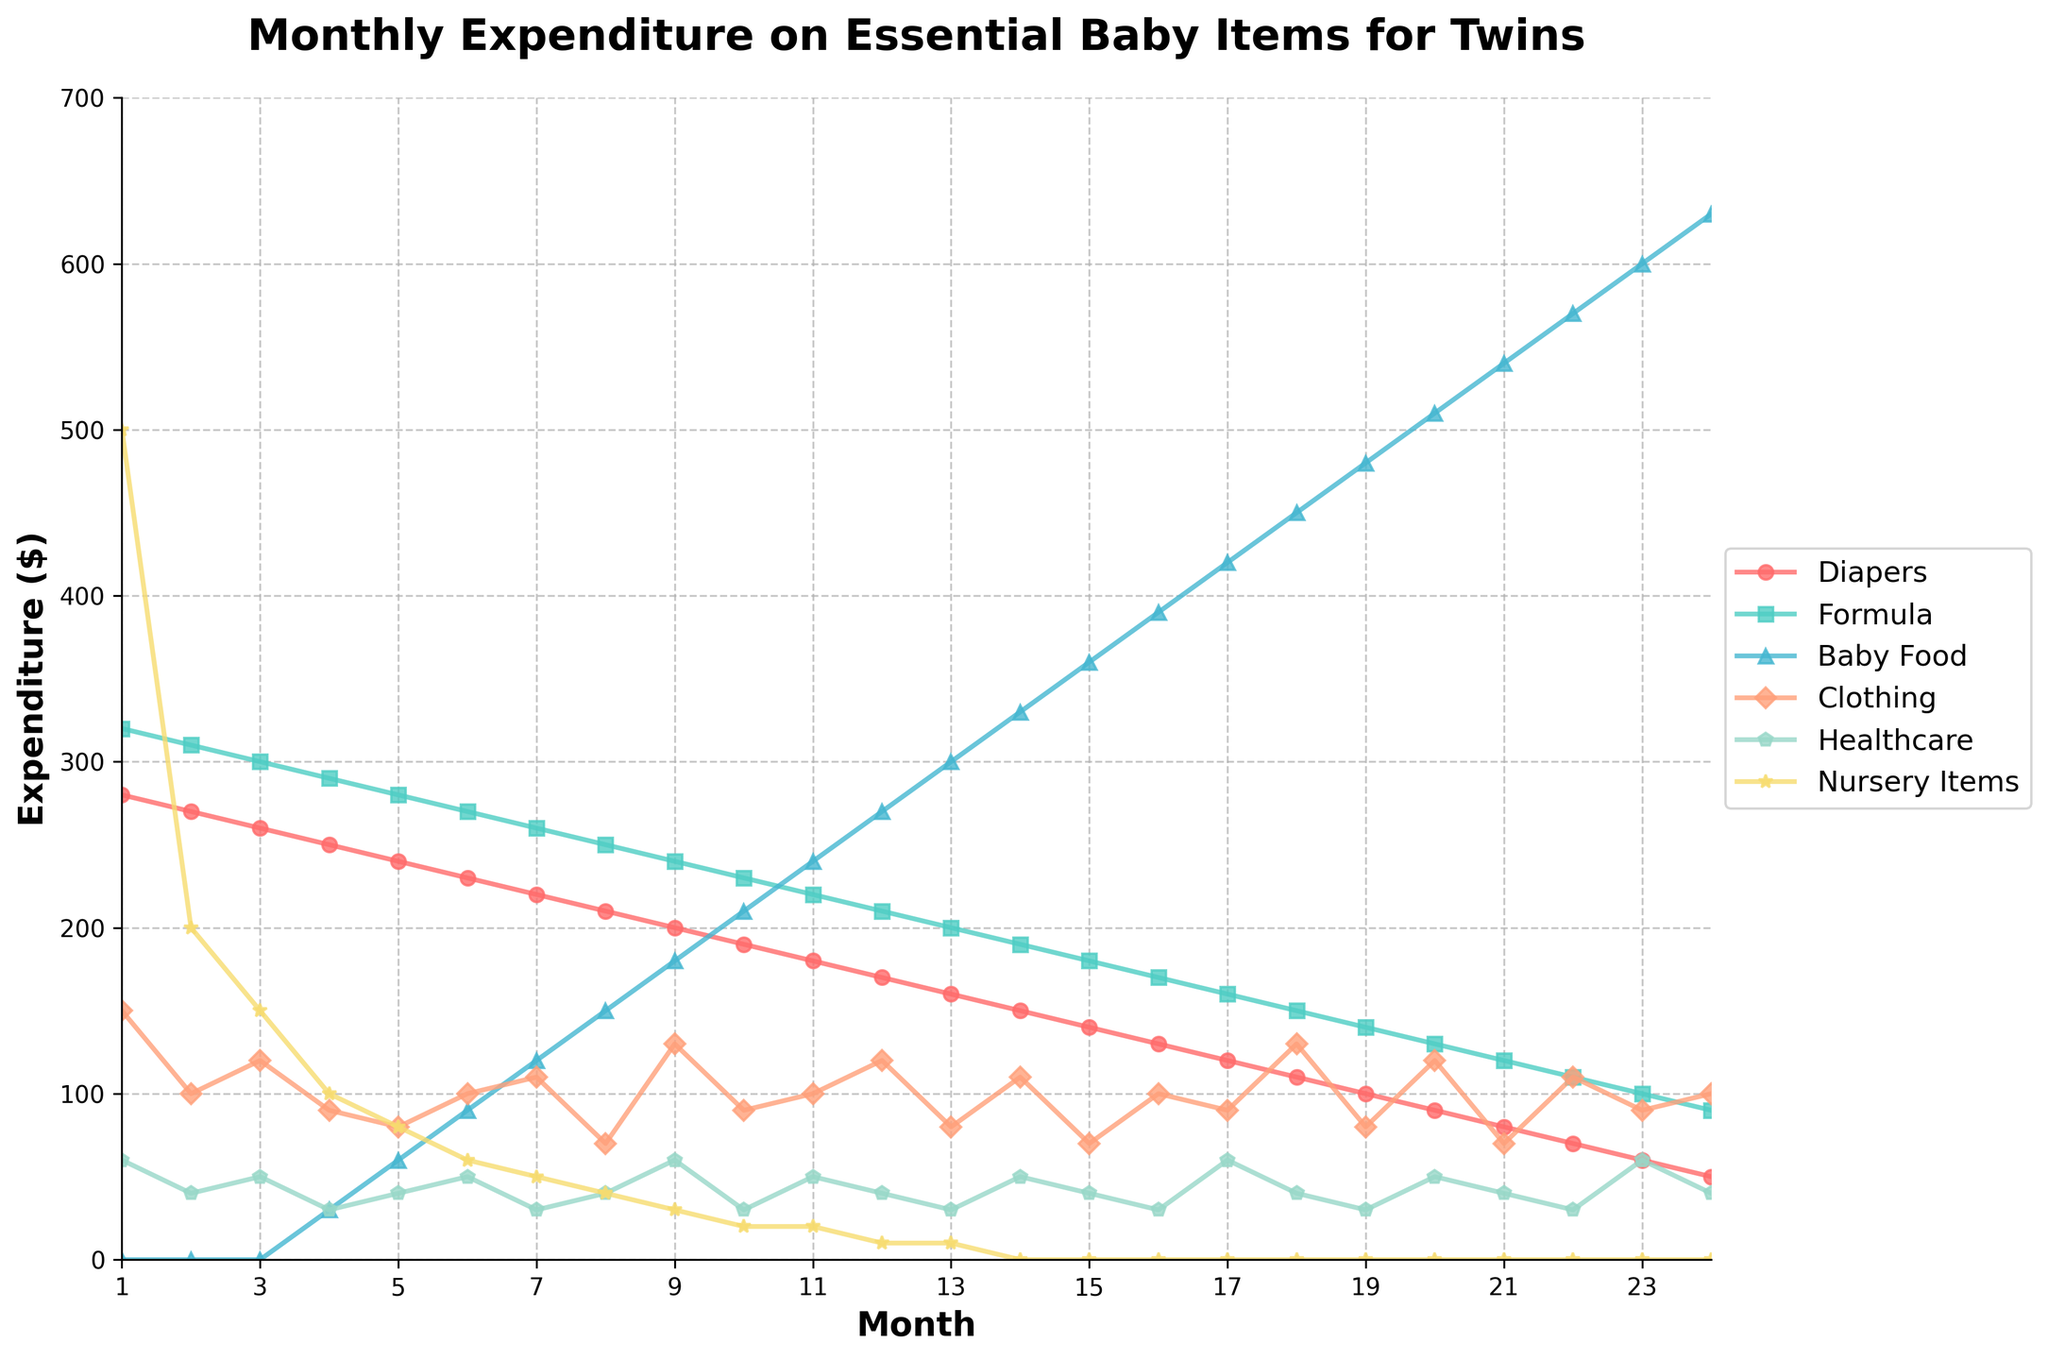What month did the expenditure on nursery items drop to zero? The plot shows a drastic and noticeable drop in the nursery item expenditure line. This line hits zero when it disappears off the chart.
Answer: Month 14 In which month did the expenditure on diapers fall below $100? The line corresponding to diapers expenditure goes below the $100 mark. This happens when the line drops below the y-axis label denoting $100.
Answer: Month 19 What is the total expenditure on healthcare in the first 6 months? To find the total expenditure on healthcare in the first 6 months, add the monthly costs: 60 + 40 + 50 + 30 + 40 + 50 = 270.
Answer: $270 During which months did formula expenditure consistently decline? Observing the formula expenditure line, it consistently decreases from its peak at Month 1 down to Day 24 without any increase between these two points.
Answer: Months 1 to 24 How does the expenditure on baby food change from Month 1 to Month 24? The baby food expenditure starts at $0 in Month 1 and increases gradually each month, reaching $630 by Month 24, as seen by the rising line on the graph.
Answer: From $0 to $630 Which item had the highest expenditure in Month 12, and what was the amount? By examining the lines at Month 12, the highest expenditure at that point is on baby food, which is indicated by the level of the line corresponding to baby food. This line is at $270.
Answer: Baby Food, $270 What is the average monthly expenditure on clothing in the first year? To get the average monthly clothing expenditure for the first 12 months, add each month's expenditure from Month 1 to Month 12 and divide by 12: (150 + 100 + 120 + 90 + 80 + 100 + 110 + 70 + 130 + 90 + 100 + 120) / 12 = 1160 / 12 = 96.67.
Answer: $96.67 In which month did healthcare costs peak, and what was the cost? By reviewing the healthcare line graph, the peak is noted by the highest point on this line. This occurs at Month 9 with a cost indicated at $60.
Answer: Month 9, $60 If the sum of expenditure on diapers and clothing in Month 15 exceeds $200? Verify by summing the expenses for diapers and clothing in Month 15: 140 (diapers) + 70 (clothing) = 210. Since 210 is greater than 200, it does exceed $200.
Answer: Yes What is the difference between the highest and lowest monthly expenditure on formula? The highest monthly expenditure on formula is $320 (Month 1), and the lowest is $90 (Month 24). The difference is 320 - 90 = 230.
Answer: $230 